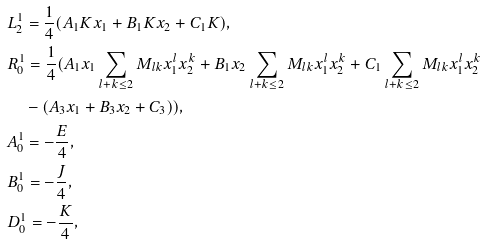Convert formula to latex. <formula><loc_0><loc_0><loc_500><loc_500>& L _ { 2 } ^ { 1 } = \frac { 1 } { 4 } ( A _ { 1 } K x _ { 1 } + B _ { 1 } K x _ { 2 } + C _ { 1 } K ) , \\ & R _ { 0 } ^ { 1 } = \frac { 1 } { 4 } ( A _ { 1 } x _ { 1 } \sum _ { l + k \leq 2 } M _ { l k } x _ { 1 } ^ { l } x _ { 2 } ^ { k } + B _ { 1 } x _ { 2 } \sum _ { l + k \leq 2 } M _ { l k } x _ { 1 } ^ { l } x _ { 2 } ^ { k } + C _ { 1 } \sum _ { l + k \leq 2 } M _ { l k } x _ { 1 } ^ { l } x _ { 2 } ^ { k } \\ & \quad - ( A _ { 3 } x _ { 1 } + B _ { 3 } x _ { 2 } + C _ { 3 } ) ) , \\ & A _ { 0 } ^ { 1 } = - \frac { E } { 4 } , \\ & B _ { 0 } ^ { 1 } = - \frac { J } { 4 } , \\ & D _ { 0 } ^ { 1 } = - \frac { K } { 4 } ,</formula> 